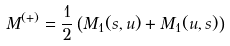<formula> <loc_0><loc_0><loc_500><loc_500>M ^ { ( + ) } = \frac { 1 } { 2 } \left ( M _ { 1 } ( s , u ) + M _ { 1 } ( u , s ) \right )</formula> 